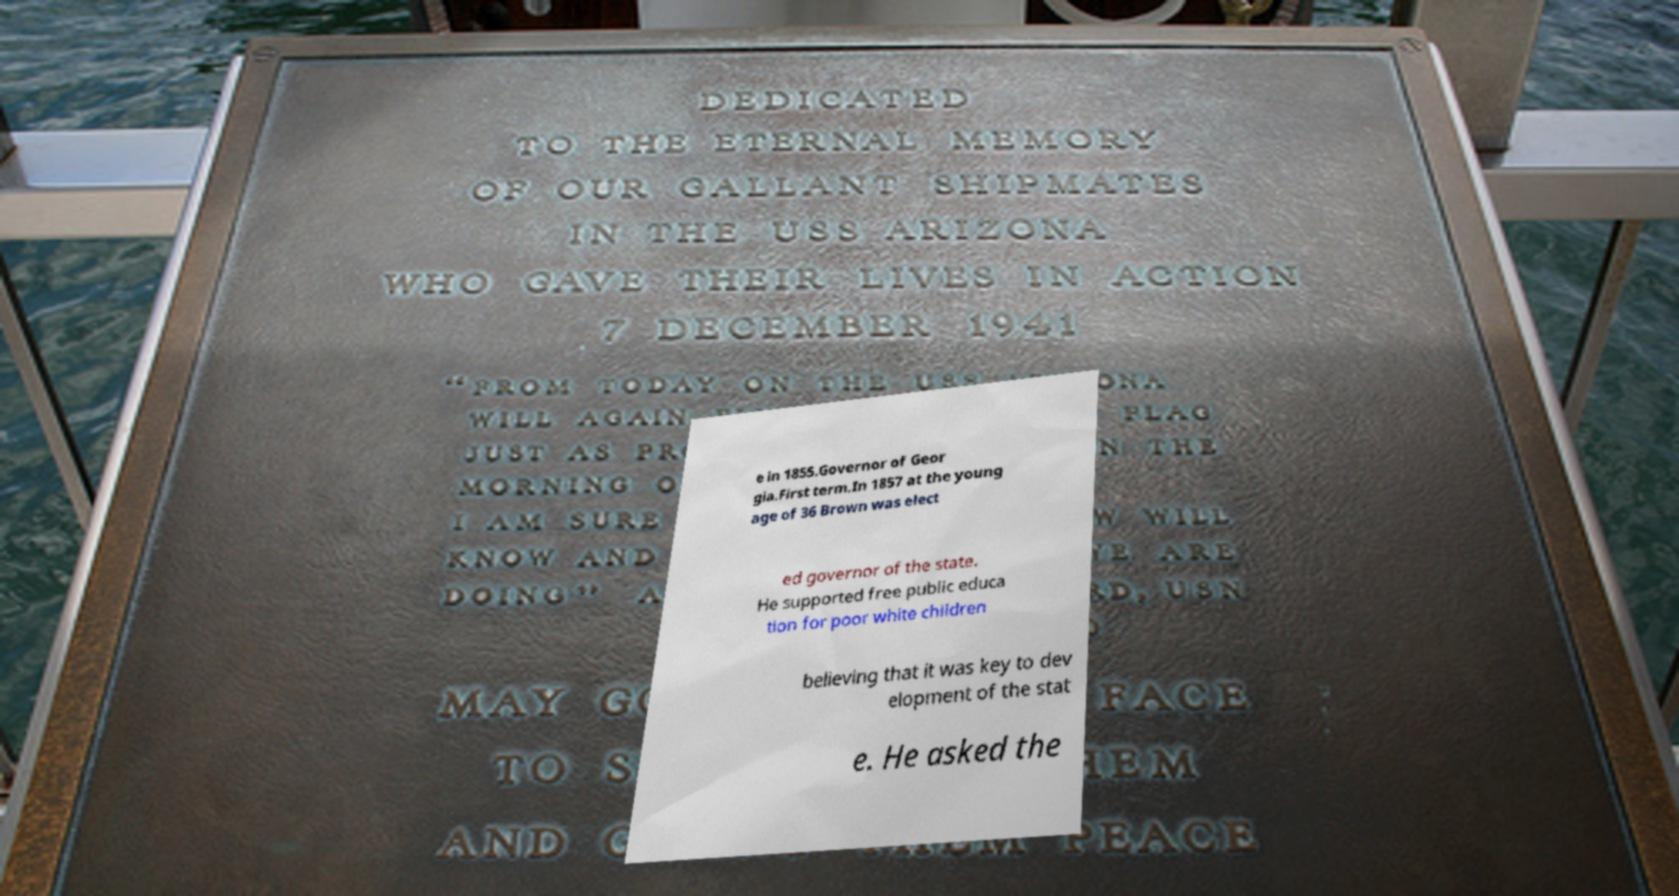There's text embedded in this image that I need extracted. Can you transcribe it verbatim? e in 1855.Governor of Geor gia.First term.In 1857 at the young age of 36 Brown was elect ed governor of the state. He supported free public educa tion for poor white children believing that it was key to dev elopment of the stat e. He asked the 